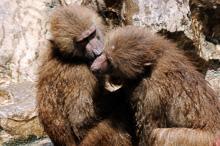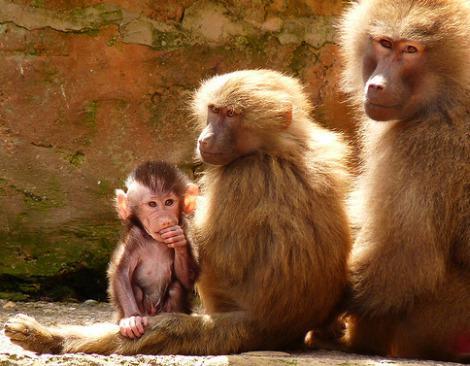The first image is the image on the left, the second image is the image on the right. Considering the images on both sides, is "A forward-facing fang-baring monkey with a lion-like mane of hair is in an image containing two animals." valid? Answer yes or no. No. The first image is the image on the left, the second image is the image on the right. Assess this claim about the two images: "The right image contains exactly two primates.". Correct or not? Answer yes or no. No. 